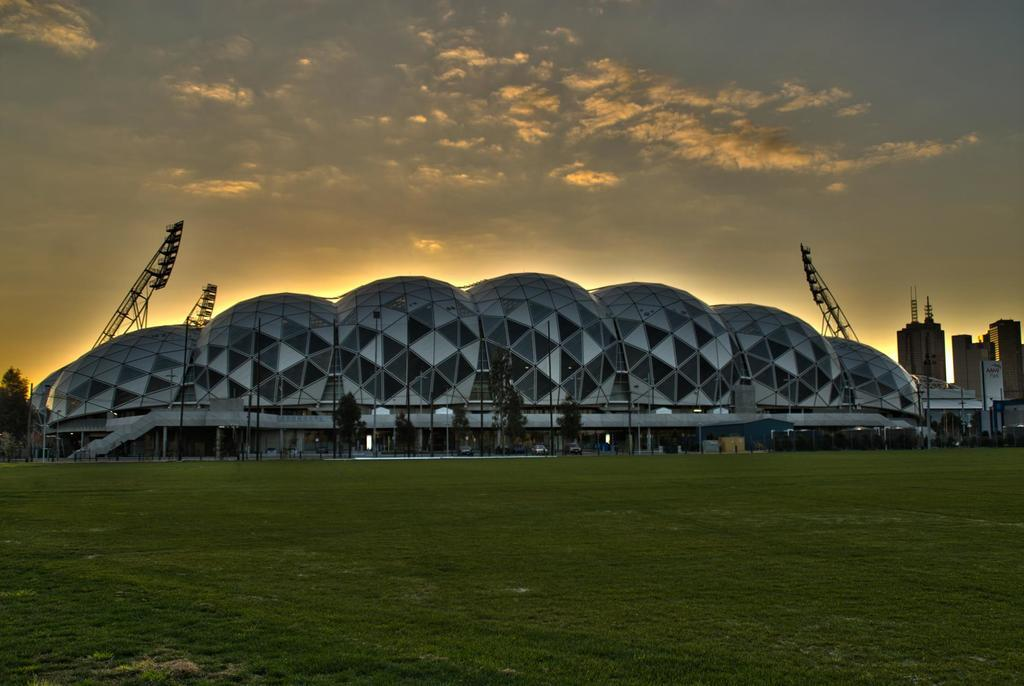What type of vegetation can be seen in the image? There are trees in the image. What type of structure is present in the image? There is a building in the image. What type of ground is visible in the image? There is grass ground in the image. How many pigs are playing in the town in the image? There are no pigs or town present in the image; it features trees, a building, and grass ground. 